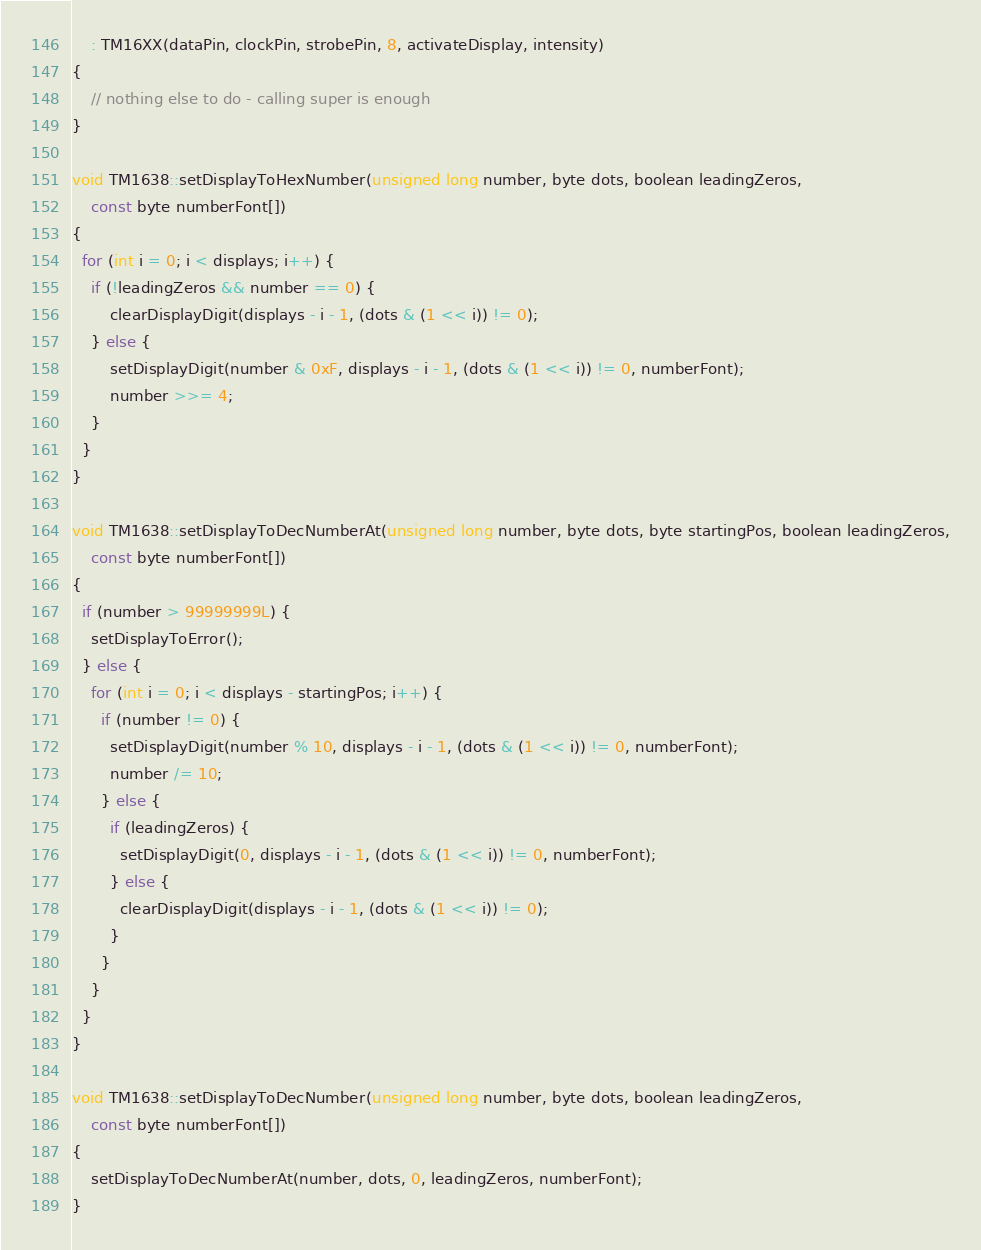<code> <loc_0><loc_0><loc_500><loc_500><_C++_>	: TM16XX(dataPin, clockPin, strobePin, 8, activateDisplay, intensity)
{
	// nothing else to do - calling super is enough
}

void TM1638::setDisplayToHexNumber(unsigned long number, byte dots, boolean leadingZeros,
	const byte numberFont[])
{
  for (int i = 0; i < displays; i++) {
	if (!leadingZeros && number == 0) {
		clearDisplayDigit(displays - i - 1, (dots & (1 << i)) != 0);
	} else {
		setDisplayDigit(number & 0xF, displays - i - 1, (dots & (1 << i)) != 0, numberFont);
		number >>= 4;
    }
  }
}

void TM1638::setDisplayToDecNumberAt(unsigned long number, byte dots, byte startingPos, boolean leadingZeros,
	const byte numberFont[])
{
  if (number > 99999999L) {
    setDisplayToError();
  } else {
    for (int i = 0; i < displays - startingPos; i++) {
      if (number != 0) {
        setDisplayDigit(number % 10, displays - i - 1, (dots & (1 << i)) != 0, numberFont);
        number /= 10;
      } else {
		if (leadingZeros) {
		  setDisplayDigit(0, displays - i - 1, (dots & (1 << i)) != 0, numberFont);
		} else {
		  clearDisplayDigit(displays - i - 1, (dots & (1 << i)) != 0);
		}
      }
    }
  }
}

void TM1638::setDisplayToDecNumber(unsigned long number, byte dots, boolean leadingZeros,
	const byte numberFont[])
{
	setDisplayToDecNumberAt(number, dots, 0, leadingZeros, numberFont);
}
</code> 